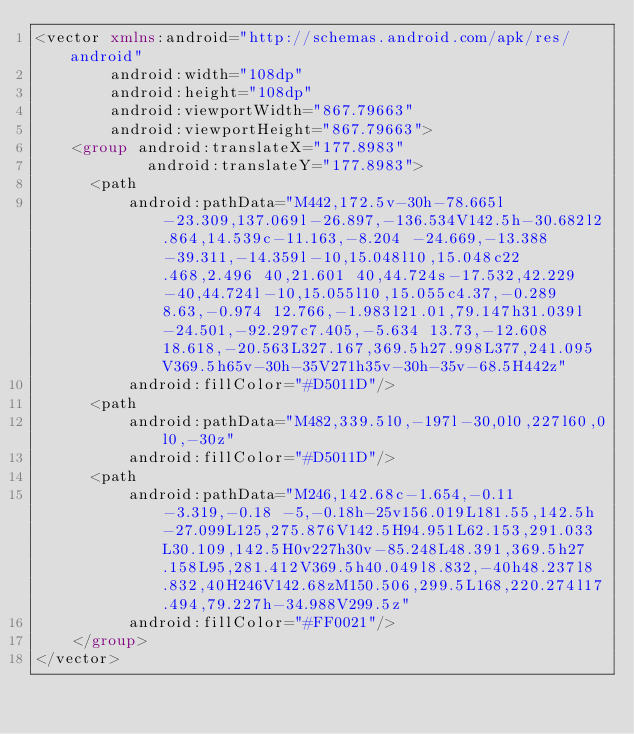<code> <loc_0><loc_0><loc_500><loc_500><_XML_><vector xmlns:android="http://schemas.android.com/apk/res/android"
        android:width="108dp"
        android:height="108dp"
        android:viewportWidth="867.79663"
        android:viewportHeight="867.79663">
    <group android:translateX="177.8983"
            android:translateY="177.8983">
      <path
          android:pathData="M442,172.5v-30h-78.665l-23.309,137.069l-26.897,-136.534V142.5h-30.682l2.864,14.539c-11.163,-8.204 -24.669,-13.388 -39.311,-14.359l-10,15.048l10,15.048c22.468,2.496 40,21.601 40,44.724s-17.532,42.229 -40,44.724l-10,15.055l10,15.055c4.37,-0.289 8.63,-0.974 12.766,-1.983l21.01,79.147h31.039l-24.501,-92.297c7.405,-5.634 13.73,-12.608 18.618,-20.563L327.167,369.5h27.998L377,241.095V369.5h65v-30h-35V271h35v-30h-35v-68.5H442z"
          android:fillColor="#D5011D"/>
      <path
          android:pathData="M482,339.5l0,-197l-30,0l0,227l60,0l0,-30z"
          android:fillColor="#D5011D"/>
      <path
          android:pathData="M246,142.68c-1.654,-0.11 -3.319,-0.18 -5,-0.18h-25v156.019L181.55,142.5h-27.099L125,275.876V142.5H94.951L62.153,291.033L30.109,142.5H0v227h30v-85.248L48.391,369.5h27.158L95,281.412V369.5h40.049l8.832,-40h48.237l8.832,40H246V142.68zM150.506,299.5L168,220.274l17.494,79.227h-34.988V299.5z"
          android:fillColor="#FF0021"/>
    </group>
</vector>
</code> 